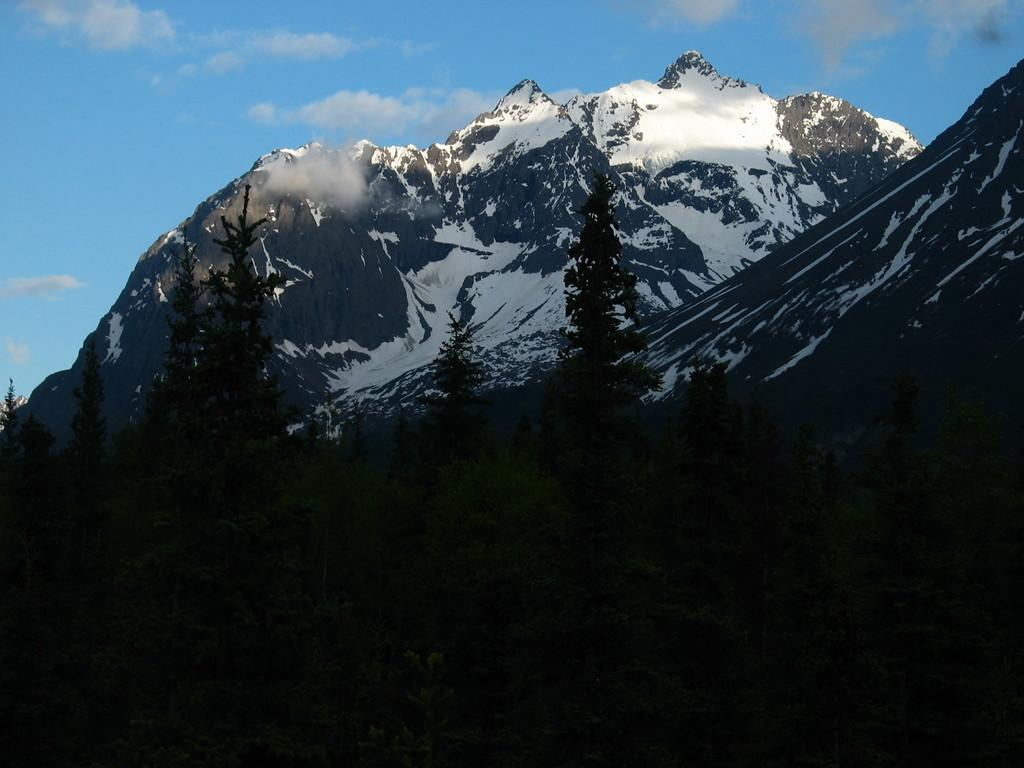What type of natural environment is depicted in the image? The image features many trees and mountains covered with snow. What can be seen in the sky in the background of the image? Clouds and the sky are visible in the background of the image. What color is the yoke of the largest tree in the image? There is no yoke present in the image, as yokes are typically associated with animals or vehicles, not trees. 